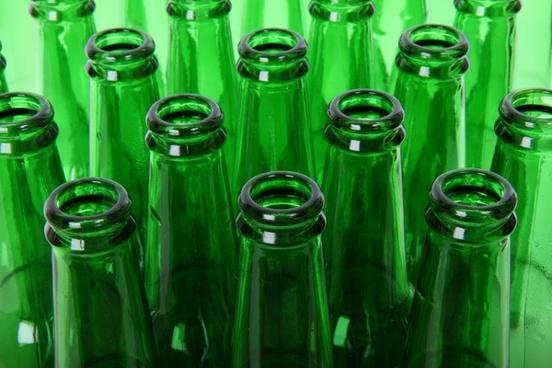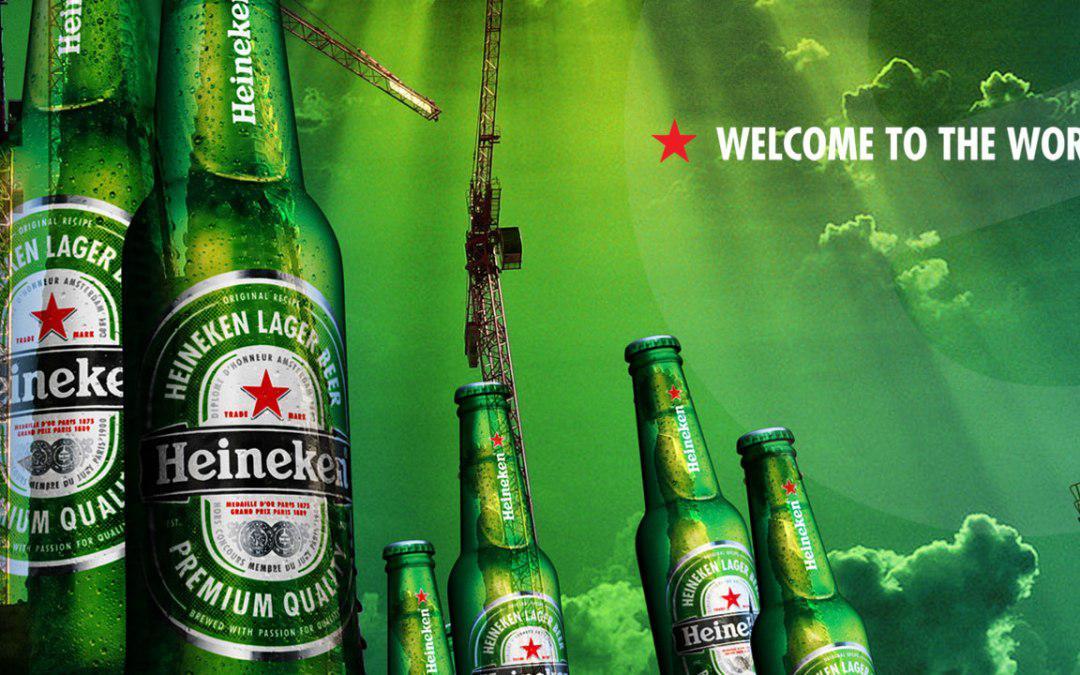The first image is the image on the left, the second image is the image on the right. Assess this claim about the two images: "An image shows one stand-out bottle with its label clearly showing, amid at least a half dozen green bottles.". Correct or not? Answer yes or no. No. The first image is the image on the left, the second image is the image on the right. Assess this claim about the two images: "In at least one image there are six green beer bottles.". Correct or not? Answer yes or no. Yes. 